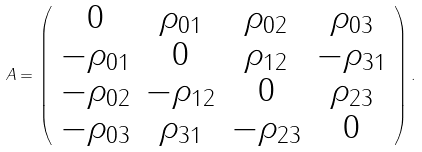<formula> <loc_0><loc_0><loc_500><loc_500>A = \left ( \begin{array} { c c c c } 0 & \rho _ { 0 1 } & \rho _ { 0 2 } & \rho _ { 0 3 } \\ - \rho _ { 0 1 } & 0 & \rho _ { 1 2 } & - \rho _ { 3 1 } \\ - \rho _ { 0 2 } & - \rho _ { 1 2 } & 0 & \rho _ { 2 3 } \\ - \rho _ { 0 3 } & \rho _ { 3 1 } & - \rho _ { 2 3 } & 0 \end{array} \right ) .</formula> 